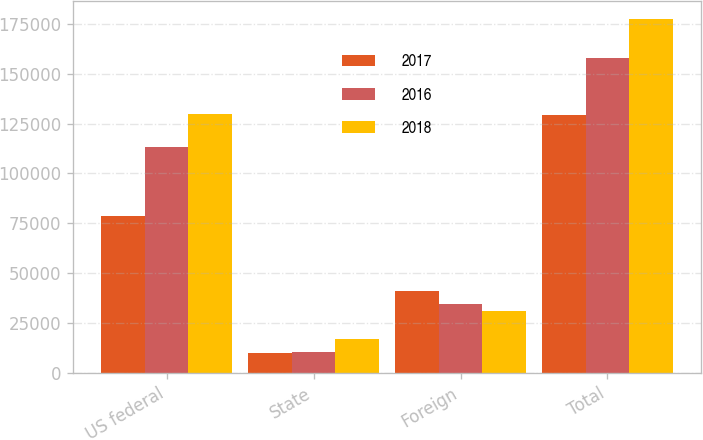Convert chart. <chart><loc_0><loc_0><loc_500><loc_500><stacked_bar_chart><ecel><fcel>US federal<fcel>State<fcel>Foreign<fcel>Total<nl><fcel>2017<fcel>78454<fcel>9800<fcel>41040<fcel>129294<nl><fcel>2016<fcel>113105<fcel>10381<fcel>34679<fcel>158165<nl><fcel>2018<fcel>129728<fcel>16821<fcel>31015<fcel>177564<nl></chart> 